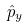<formula> <loc_0><loc_0><loc_500><loc_500>\hat { p } _ { y }</formula> 